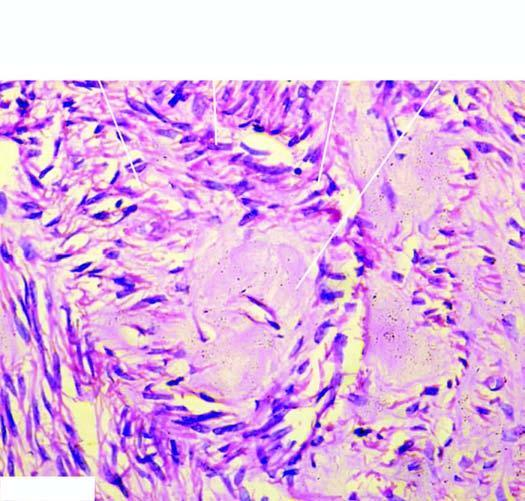do the centres of whorls of smooth muscle and connective tissue show pink homogeneous hyaline material connective tissue hyaline?
Answer the question using a single word or phrase. Yes 